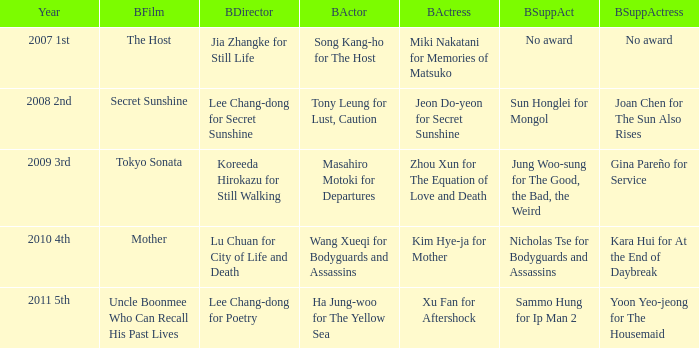Which director is considered the best for the film "mother"? Lu Chuan for City of Life and Death. 